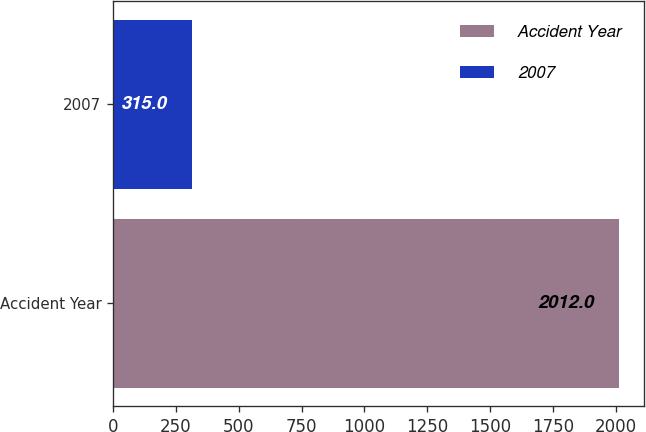<chart> <loc_0><loc_0><loc_500><loc_500><bar_chart><fcel>Accident Year<fcel>2007<nl><fcel>2012<fcel>315<nl></chart> 